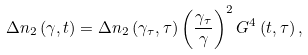<formula> <loc_0><loc_0><loc_500><loc_500>\Delta n _ { 2 } \left ( \gamma , t \right ) = \Delta n _ { 2 } \left ( \gamma _ { \tau } , \tau \right ) \left ( \frac { \gamma _ { \tau } } { \gamma } \right ) ^ { 2 } G ^ { 4 } \left ( t , \tau \right ) ,</formula> 